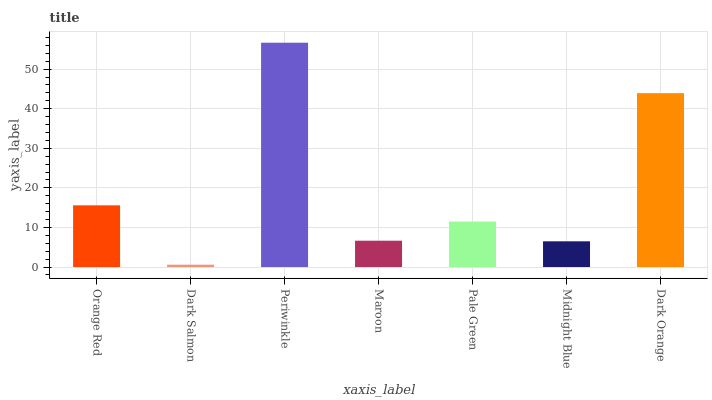Is Dark Salmon the minimum?
Answer yes or no. Yes. Is Periwinkle the maximum?
Answer yes or no. Yes. Is Periwinkle the minimum?
Answer yes or no. No. Is Dark Salmon the maximum?
Answer yes or no. No. Is Periwinkle greater than Dark Salmon?
Answer yes or no. Yes. Is Dark Salmon less than Periwinkle?
Answer yes or no. Yes. Is Dark Salmon greater than Periwinkle?
Answer yes or no. No. Is Periwinkle less than Dark Salmon?
Answer yes or no. No. Is Pale Green the high median?
Answer yes or no. Yes. Is Pale Green the low median?
Answer yes or no. Yes. Is Periwinkle the high median?
Answer yes or no. No. Is Dark Salmon the low median?
Answer yes or no. No. 